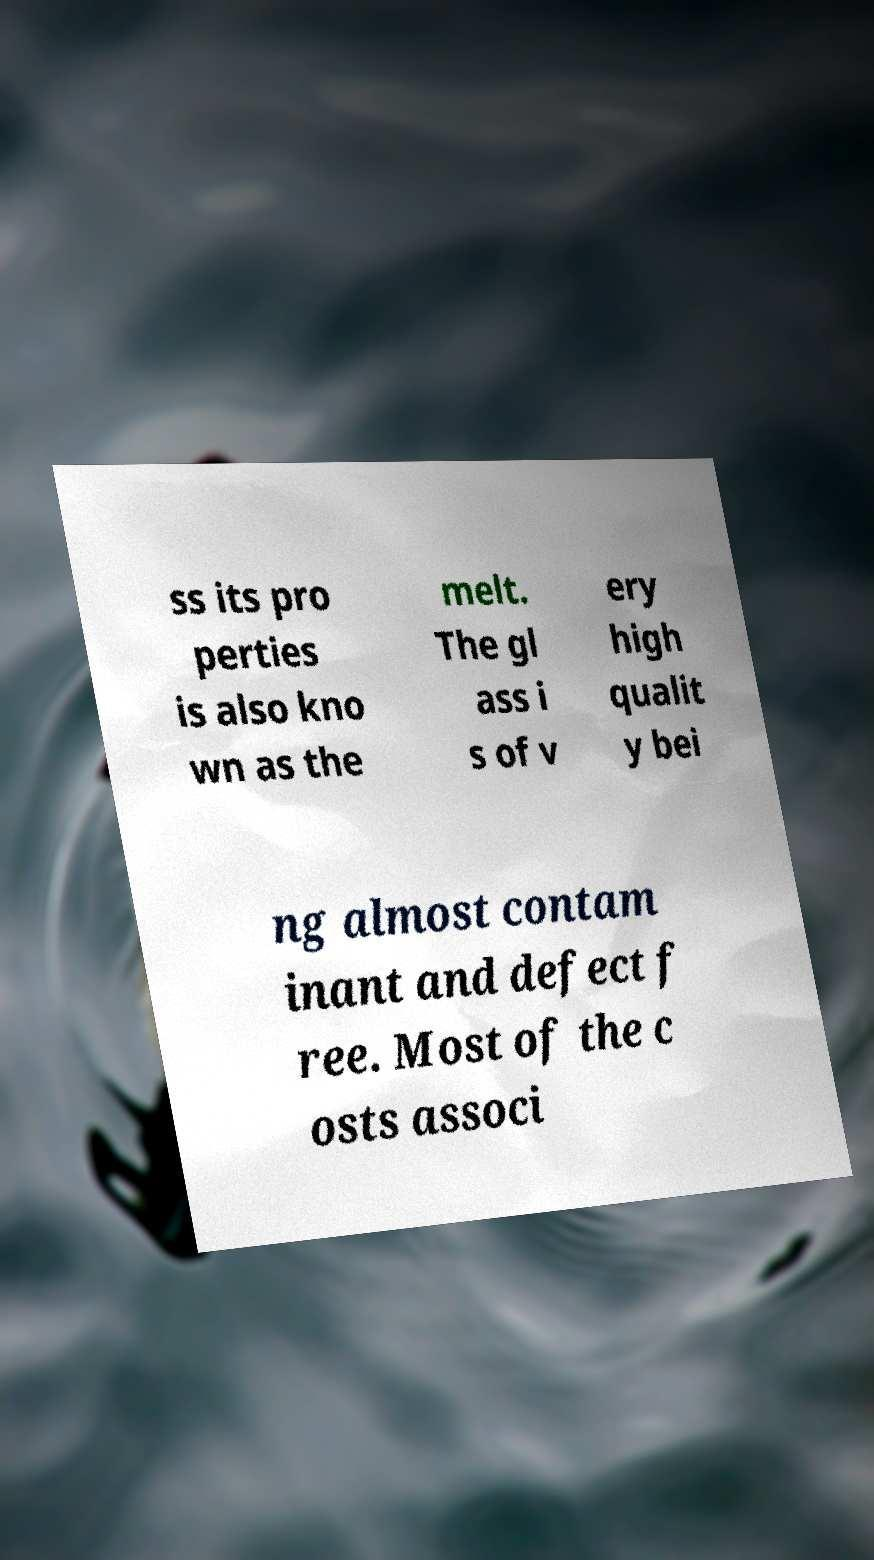I need the written content from this picture converted into text. Can you do that? ss its pro perties is also kno wn as the melt. The gl ass i s of v ery high qualit y bei ng almost contam inant and defect f ree. Most of the c osts associ 